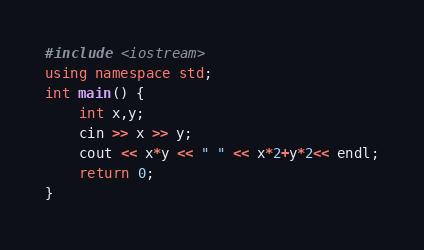Convert code to text. <code><loc_0><loc_0><loc_500><loc_500><_C++_>#include <iostream>
using namespace std;
int main() {
	int x,y;
	cin >> x >> y;
	cout << x*y << " " << x*2+y*2<< endl;
	return 0;
}</code> 